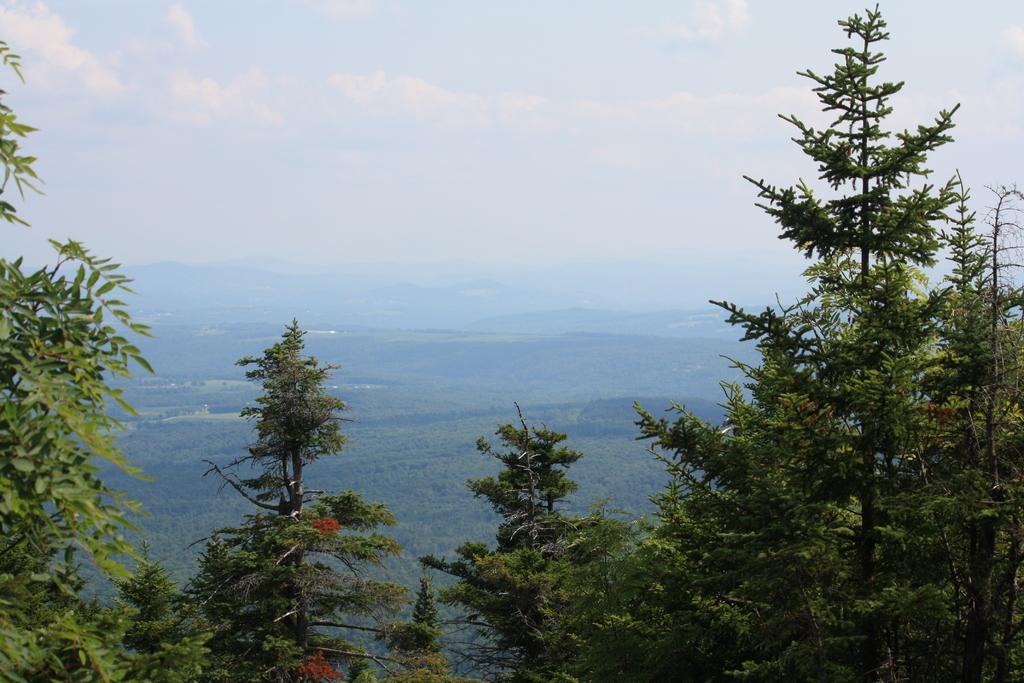How would you summarize this image in a sentence or two? In this image I can see few trees in the front. In the background I can see number of trees, mountains, clouds and the sky. 